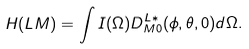Convert formula to latex. <formula><loc_0><loc_0><loc_500><loc_500>H ( L M ) = \int I ( \Omega ) D ^ { L \ast } _ { M 0 } ( \phi , \theta , 0 ) d \Omega .</formula> 